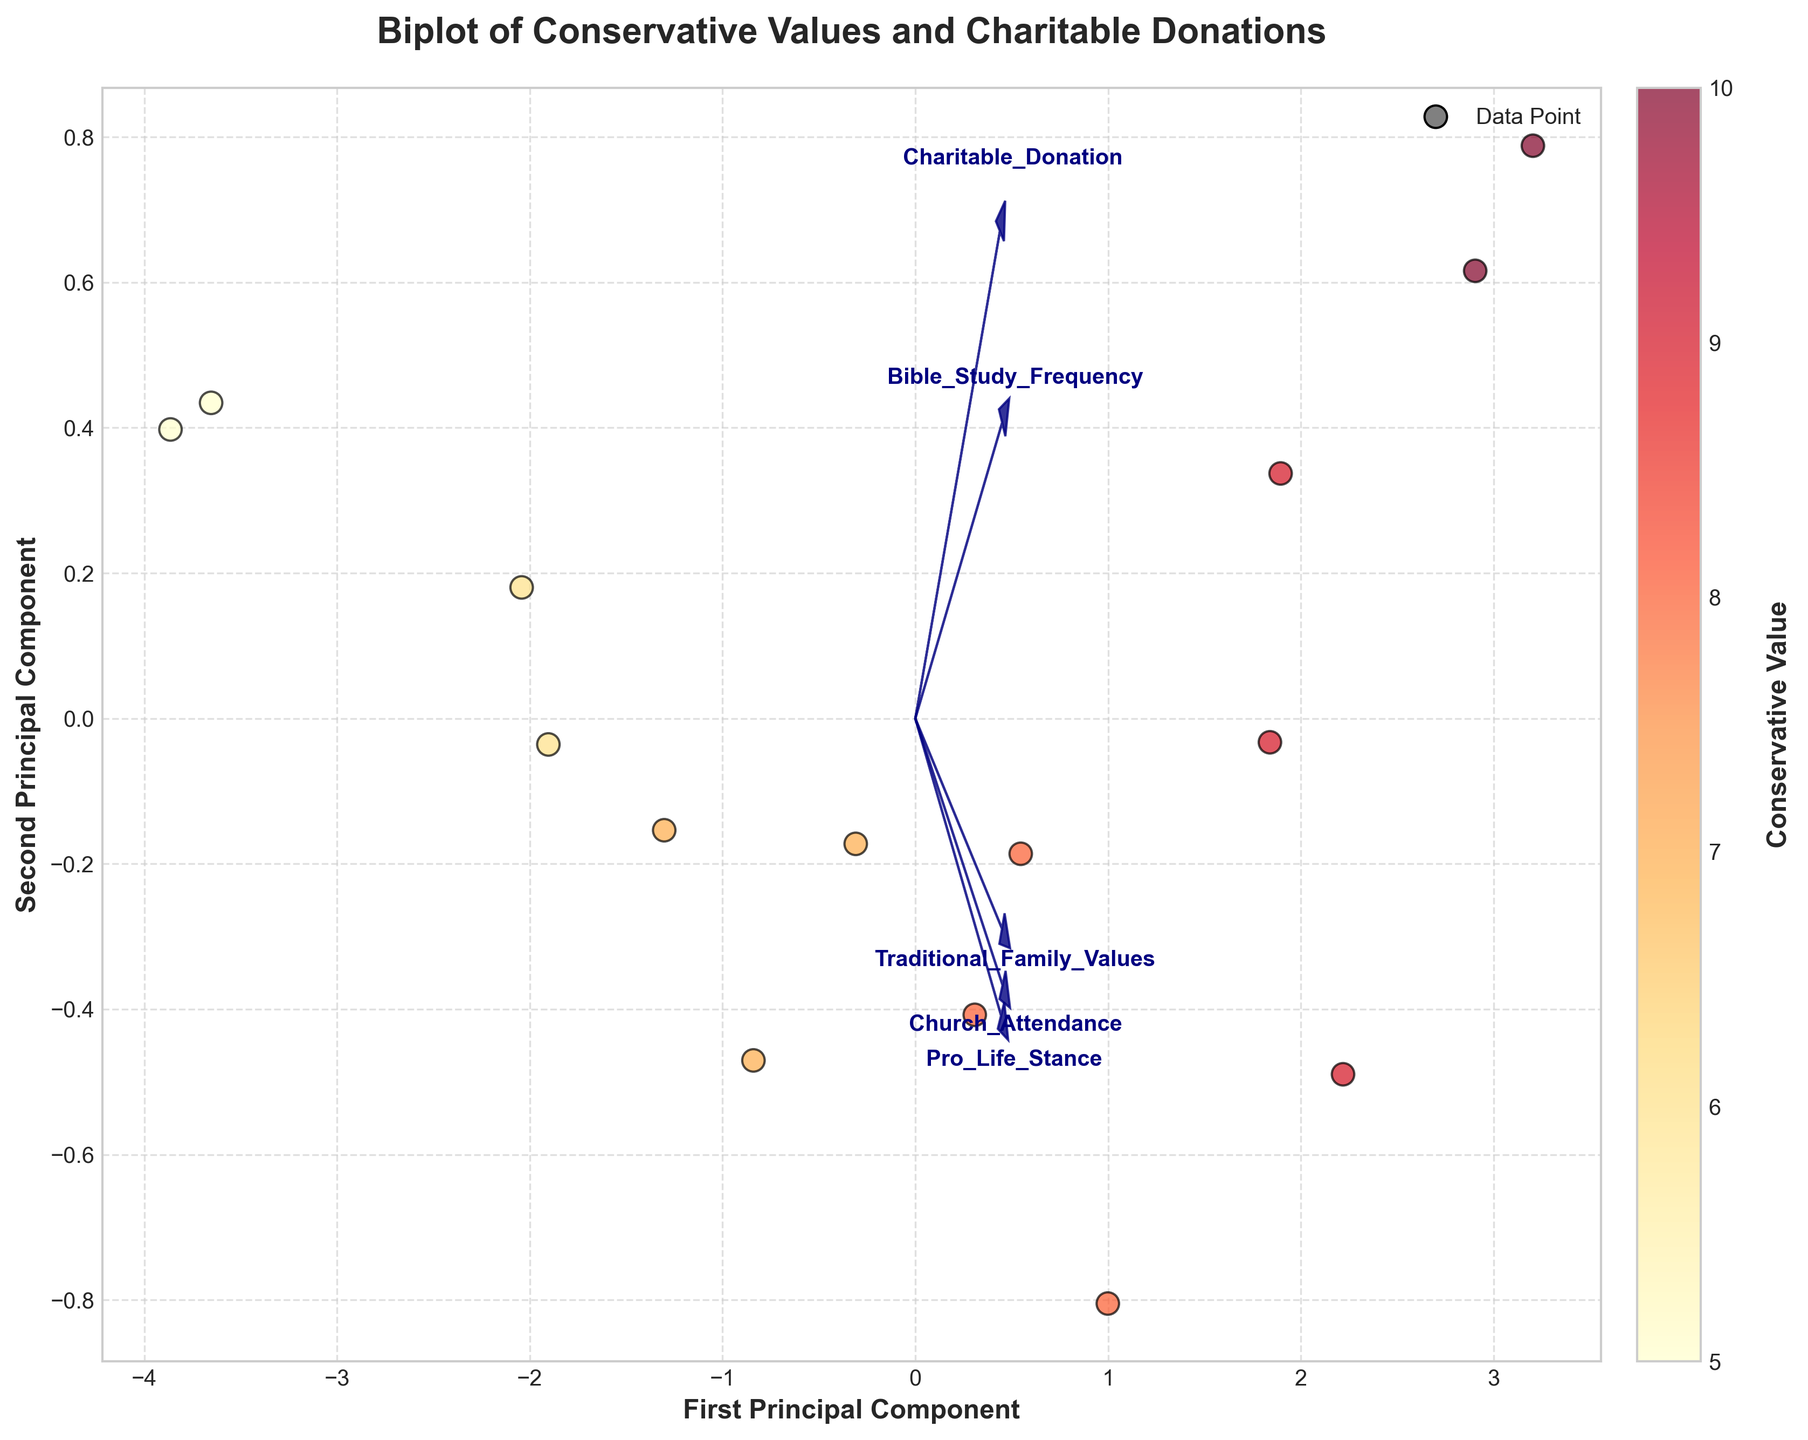What does the color indicate in this biplot? The color indicates the conservative values of the data points, with varying shades from light yellow to dark red representing different levels of conservatism. This can be seen in the color bar on the right side of the figure.
Answer: Conservative values How many principal components are shown in this biplot? The biplot displays two principal components, as labeled on the axes: "First Principal Component" and "Second Principal Component."
Answer: Two What's the range of Charitable Donation amounts represented by the arrows in the plot? By observing where the arrow for "Charitable_Donation" extends, the range on the plot shows how this variable influences the principal components. It generally spans across both axes.
Answer: Both axes Which feature vector contributes most to the first principal component? By examining the direction and length of the arrows, the vector for "Church_Attendance" has a significant length and alignment with the direction of the first principal component axis, indicating a high contribution.
Answer: Church Attendance Which two feature vectors are most closely aligned? The arrows for "Traditional Family Values" and "Pro Life Stance" are closely aligned in direction, demonstrating that these two features have a similar influence on the principal components.
Answer: Traditional Family Values and Pro Life Stance Which data point has the highest conservative value? The data point with the darkest red color, located at the uppermost part of the range in the color bar, indicates the highest conservative value.
Answer: Conservative Value of 10 How does Church Attendance correlate with Charitable Donations? The arrows for "Church_Attendance" and "Charitable_Donation" point in similar directions, suggesting a positive correlation between these two features.
Answer: Positive correlation Which two data points have the most similar values across all visual features? Data points that are closest together on the biplot, with similar color shading, indicate similarities in conservative value, Church attendance, Charitable Donation, etc.
Answer: Points near the center How do Traditional Family Values and Bible Study Frequency relate visually in the biplot? The arrows for these features point in different directions, indicating that they might not be closely correlated in the dataset.
Answer: Not closely correlated What is the spread of the conservative values across data points? The scatter points display a range from light yellow (lower conservative values) to dark red (higher conservative values) across the biplot, showing an extensive spread.
Answer: Extensive spread from low to high 